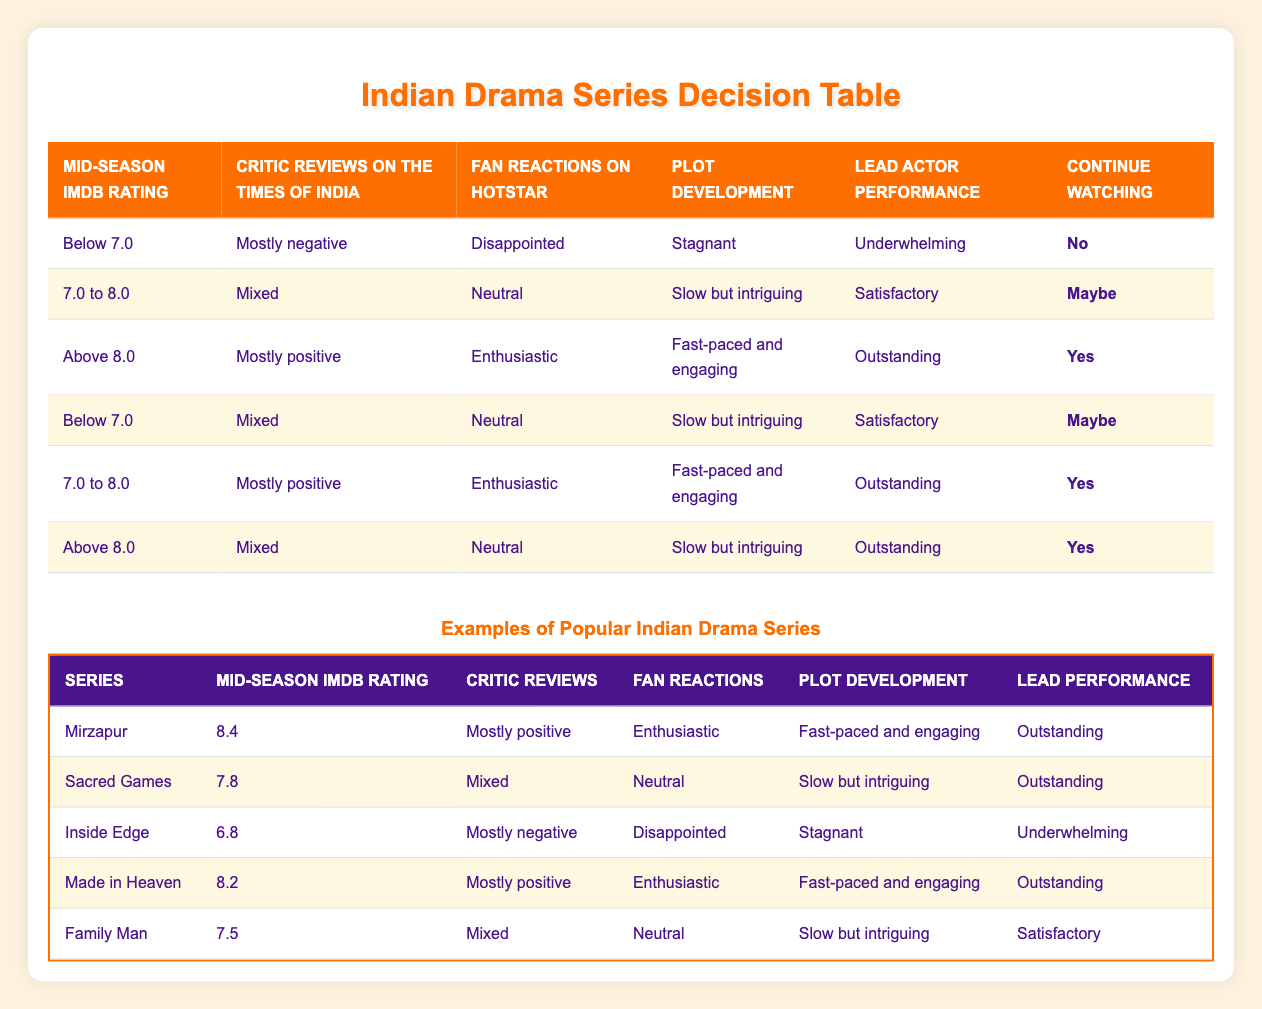What is the mid-season IMDb rating for "Inside Edge"? From the examples table, I find that "Inside Edge" has a mid-season IMDb rating of 6.8.
Answer: 6.8 How many series have a lead performance rated as "Outstanding"? By reviewing the examples table, I count "Mirzapur," "Made in Heaven," and "Sacred Games," which totals 3 series with an "Outstanding" lead performance.
Answer: 3 Is the plot development for "Family Man" described as fast-paced and engaging? Looking at the "Family Man" row in the examples table, the plot development is noted as "Slow but intriguing," which means it is not fast-paced and engaging.
Answer: No What is the decision outcome for the series that received mostly negative critic reviews and have a mid-season IMDb rating below 7.0? Referring to the rules, if a series has a mid-season rating "Below 7.0," "Mostly negative" reviews, "Disappointed" fan reactions, "Stagnant" plot development, and "Underwhelming" lead performance, the decision is "No." Hence, "Inside Edge" falls into this category.
Answer: No For series with an IMDb rating between 7.0 to 8.0, what percentage continues watching? The series "Family Man" has a decision option of "Maybe," while the series with a decision option of "Yes" under this rating is "Sacred Games." There are two instances, leading to a percentage of 50%.
Answer: 50% Which series had the highest-rated mid-season IMDb rating? I look through the mid-season IMDb ratings and identify that "Mirzapur" has the highest rating of 8.4 among all listed series.
Answer: 8.4 If a series has an IMDb rating above 8.0 and mixed reviews, what is the likely decision on watching it? Referring to the rules, if the conditions are an IMDb rating "Above 8.0" and "Mixed" reviews, the action decided is "Yes," as evidenced by the respective rule that confirms this outcome.
Answer: Yes What is the plot development description for the series with mixed fan reactions and satisfactory lead performance? Checking the examples, "Family Man" has "Slow but intriguing" as its plot development description, while it has "Mixed" fan reactions and a "Satisfactory" lead performance.
Answer: Slow but intriguing 